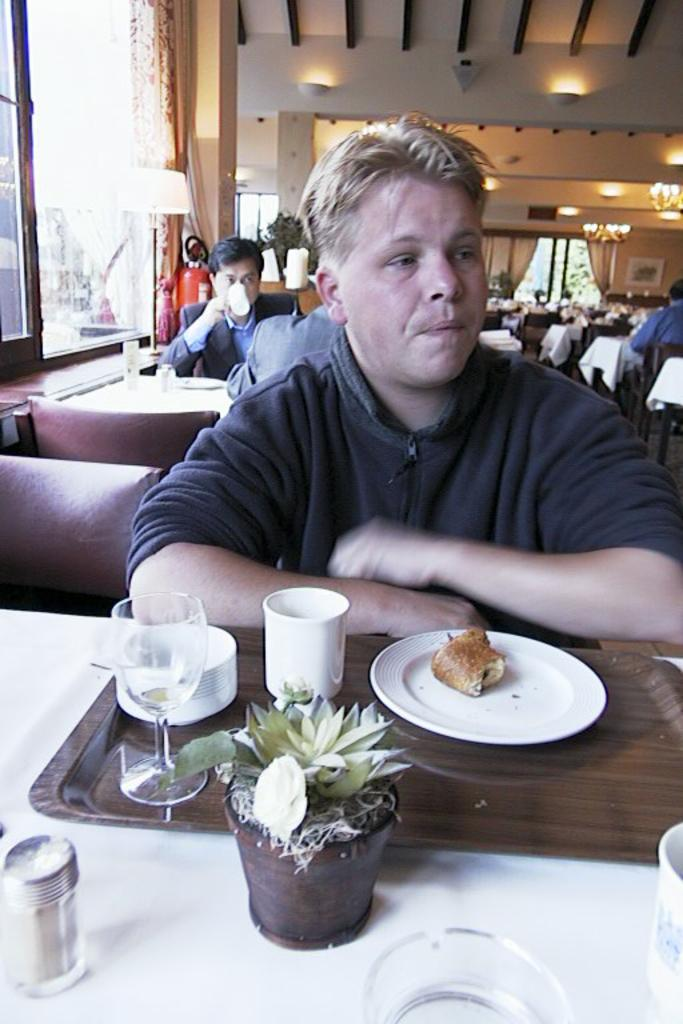What is the person in the image doing? The person is sitting on a chair at a table. What objects can be seen on the table? There is a glass, a cup, a plate, food, and a flower vase on the table. Are there any other people in the image? Yes, there are people behind the person. What are the people behind the person doing? The provided facts do not specify what the people behind the person are doing. What song is the person singing in the image? There is no indication in the image that the person is singing a song. What type of frame surrounds the image? The provided facts do not mention a frame surrounding the image. 